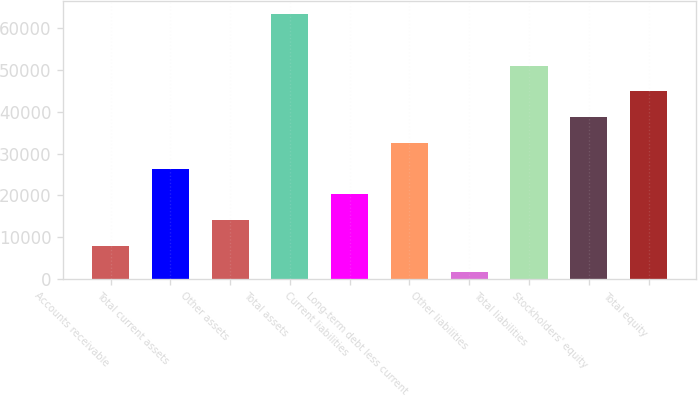<chart> <loc_0><loc_0><loc_500><loc_500><bar_chart><fcel>Accounts receivable<fcel>Total current assets<fcel>Other assets<fcel>Total assets<fcel>Current liabilities<fcel>Long-term debt less current<fcel>Other liabilities<fcel>Total liabilities<fcel>Stockholders' equity<fcel>Total equity<nl><fcel>7868.3<fcel>26403.2<fcel>14046.6<fcel>63473<fcel>20224.9<fcel>32581.5<fcel>1690<fcel>51116.4<fcel>38759.8<fcel>44938.1<nl></chart> 